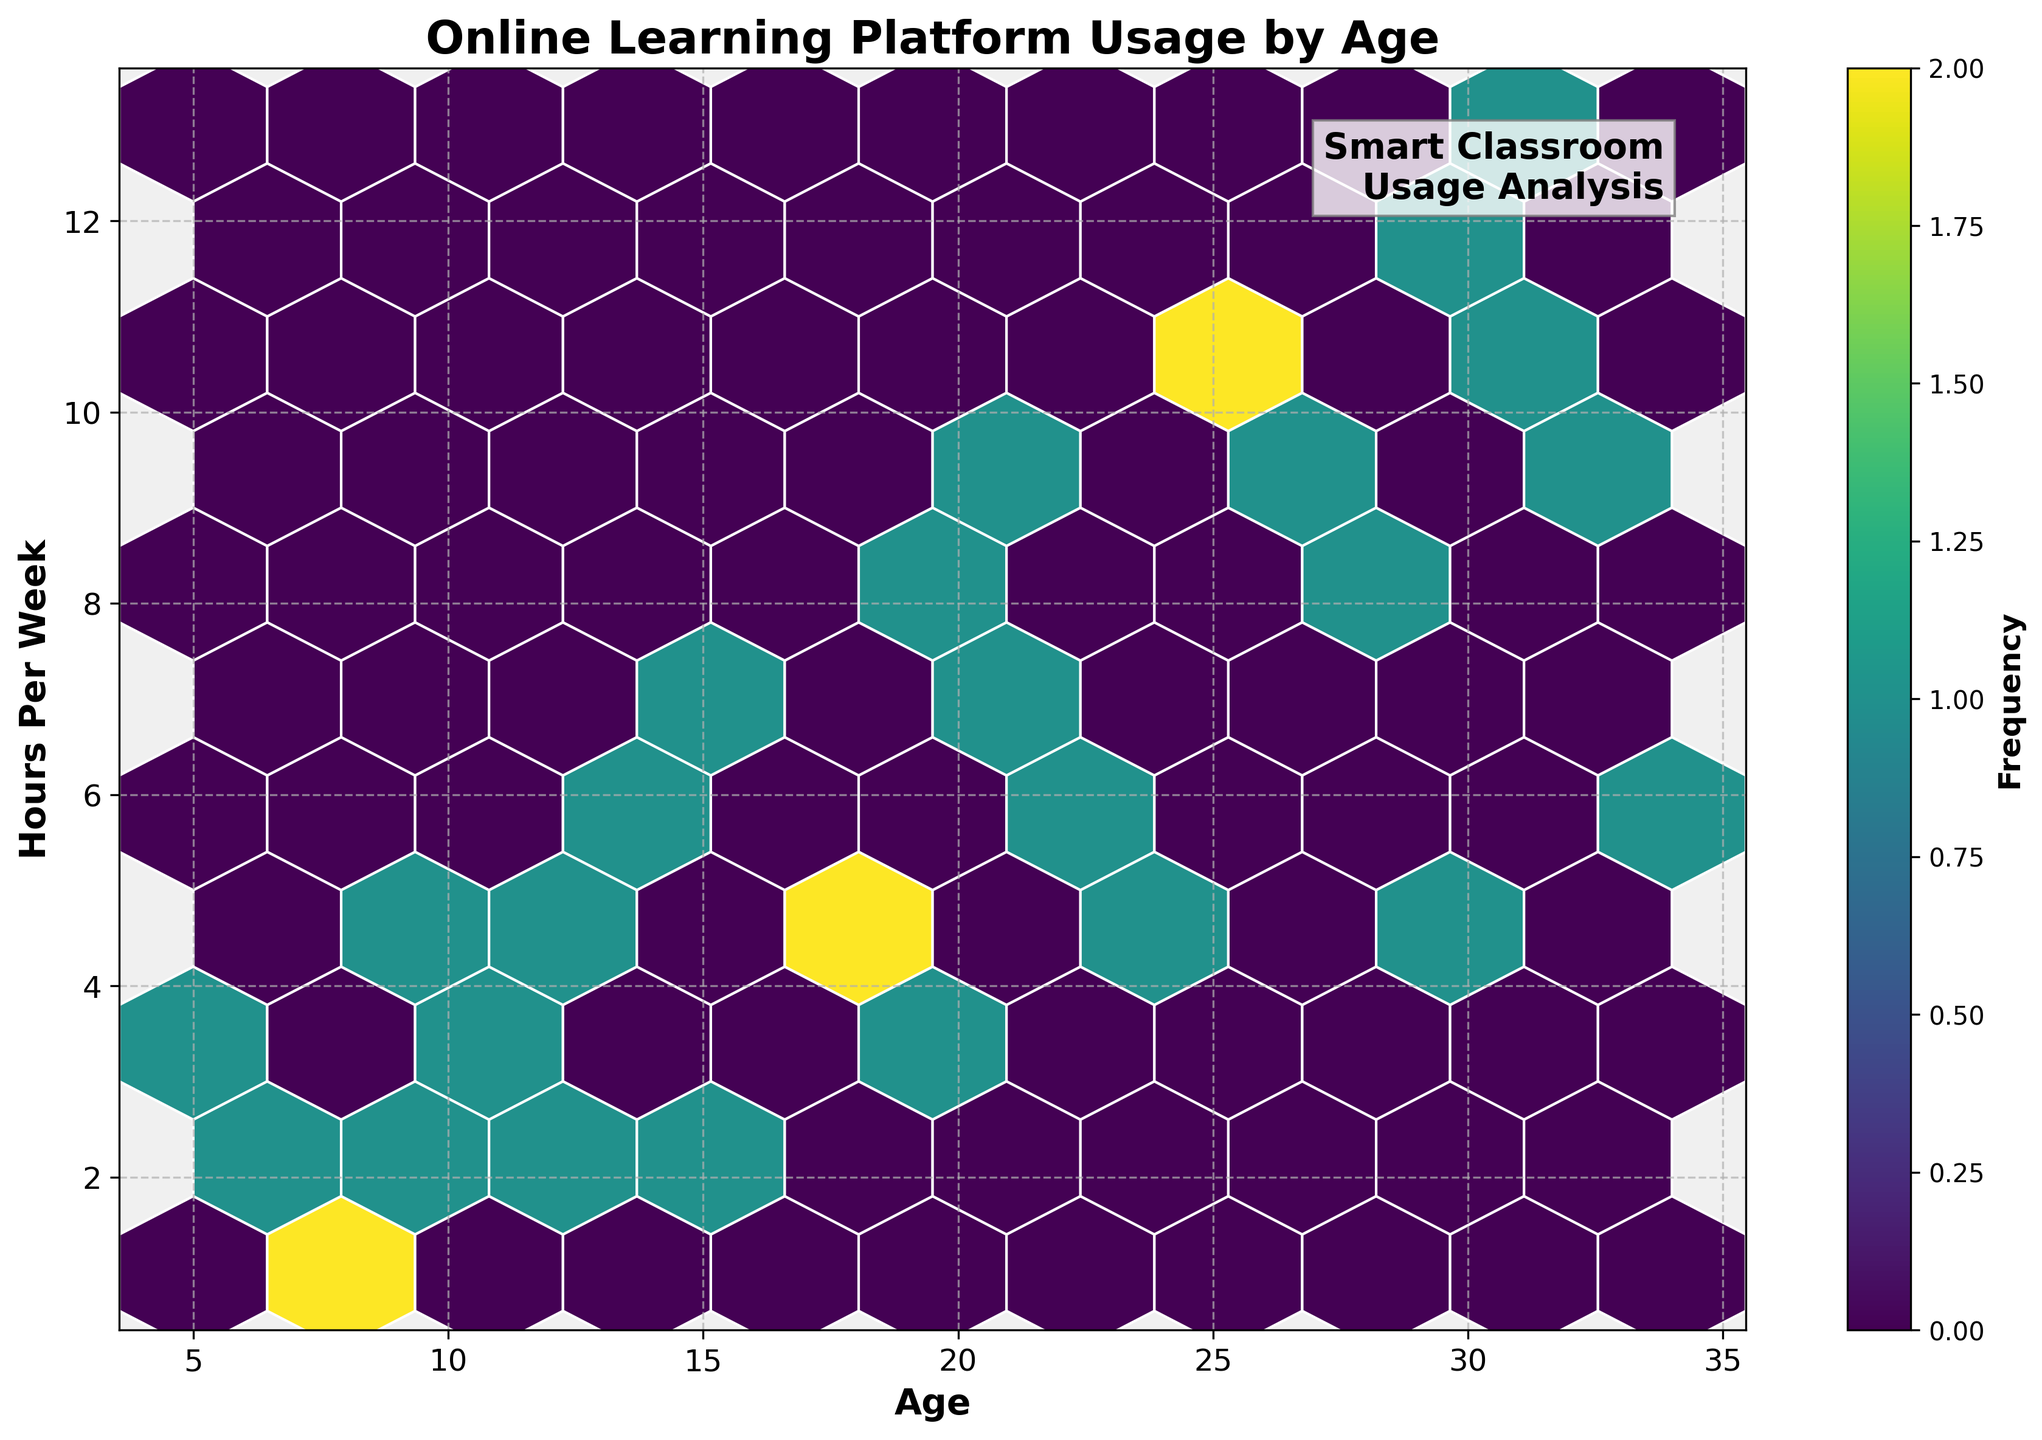What is the title of the hexbin plot? The title of the plot is typically located at the top and is in a larger, bold font. In this plot, the title is "Online Learning Platform Usage by Age."
Answer: Online Learning Platform Usage by Age What are the labels on the x and y axes? The labels describe the data represented by each axis. The x-axis label is 'Age,' and the y-axis label is 'Hours Per Week.'
Answer: Age and Hours Per Week What does the color of the hexagons represent in the plot? The colors represent the frequency of data points within each hexagon. This is shown with a colorbar on the plot, indicating that colors range correlates with different frequencies.
Answer: Frequency of data points How does the frequency of online learning usage change from ages 25 to 30 in terms of hours per week? By observing the hexbin plot for ages 25 to 30 along the x-axis and corresponding y-values, it is visible how darker hexagons (higher frequency) generally trend towards higher hours per week.
Answer: Higher frequency for higher hours per week What is the maximum number of hours per week spent on online learning by individuals aged 10 or lower? To find this, look at the hexagons corresponding to ages 5 to 10 on the x-axis. The highest y-value in that range represents the maximum hours per week.
Answer: 4 hours per week Are there any age groups where online learning usage exceeds 10 hours per week? Inspect the plot to see if any hexagons are present at y-values greater than 10 for any age groups. There are such hexagons visible for certain age groups.
Answer: Yes, for ages 25 to 34 Which age group has the widest variation in hours per week spent on online learning? The widest variation would show hexagons spread over a larger range of y-values for a particular age group. Ages like 25 to 34 show a wide spread of y-values.
Answer: Ages 25 to 34 How does the online learning usage at age 15 compare to that at age 30? By comparing the hexagons at x-values 15 and 30, we can observe the differences in y-values and frequencies. Age 30 generally has higher y-values, indicating more hours per week.
Answer: Age 30 has higher usage What is the overall trend of online learning usage across different age groups? By looking at the general distribution of hexagons from left to right, it can be seen that as age increases, there is a general upward trend in hours per week.
Answer: Increases with age How does the frequency distribution help in determining the most popular age group for online learning? The frequency, indicated by the color intensity, helps identify age groups with more data points. Darker regions show age groups with higher platform usage, making them more popular.
Answer: Helps identify popular age groups with higher usage 